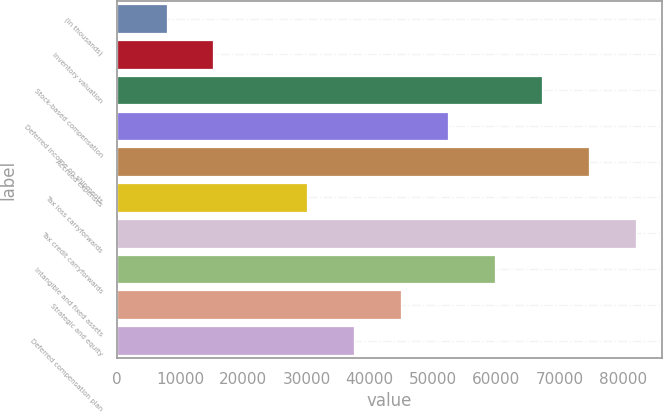<chart> <loc_0><loc_0><loc_500><loc_500><bar_chart><fcel>(In thousands)<fcel>Inventory valuation<fcel>Stock-based compensation<fcel>Deferred income on shipments<fcel>Accrued expenses<fcel>Tax loss carryforwards<fcel>Tax credit carryforwards<fcel>Intangible and fixed assets<fcel>Strategic and equity<fcel>Deferred compensation plan<nl><fcel>7867.4<fcel>15293.8<fcel>67278.6<fcel>52425.8<fcel>74705<fcel>30146.6<fcel>82131.4<fcel>59852.2<fcel>44999.4<fcel>37573<nl></chart> 